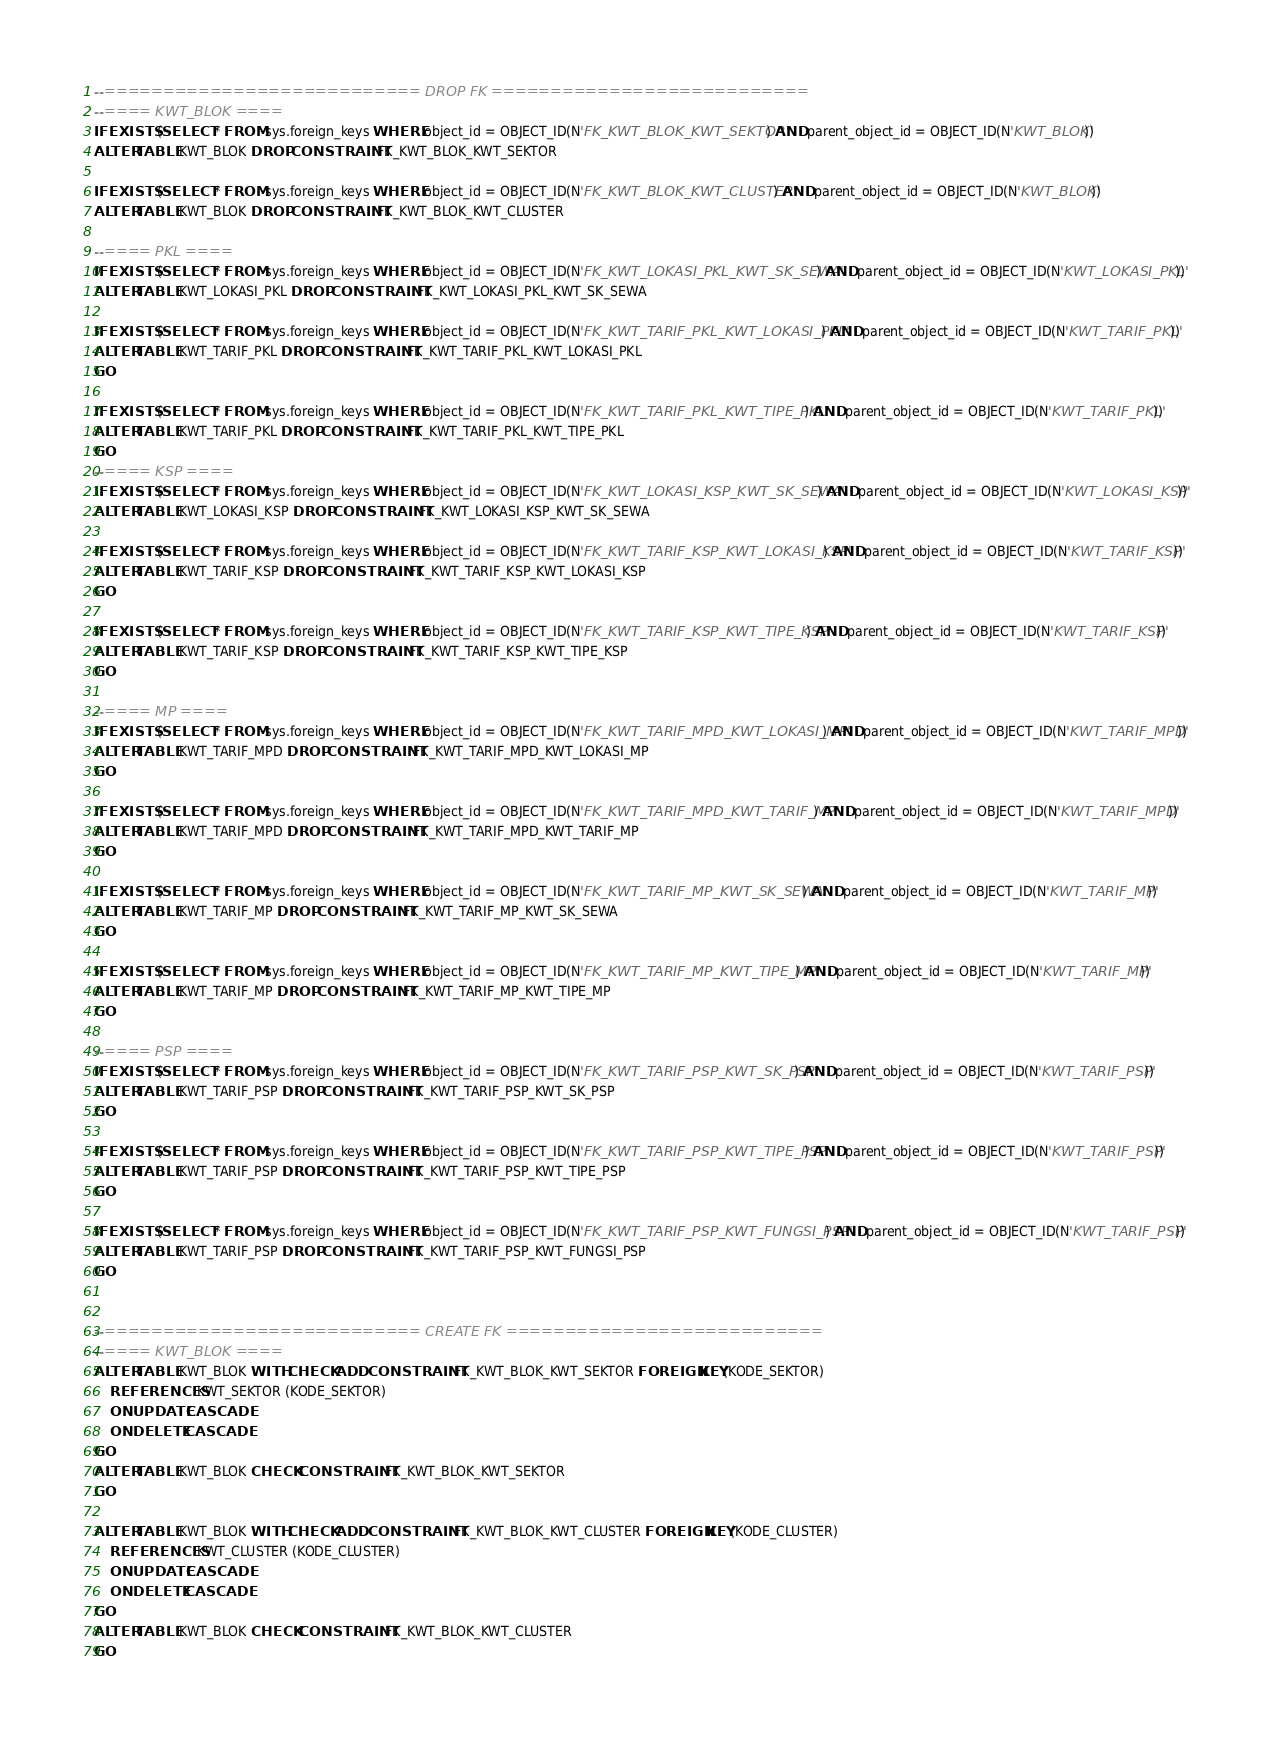Convert code to text. <code><loc_0><loc_0><loc_500><loc_500><_SQL_>--=========================== DROP FK ===========================
--==== KWT_BLOK ====
IF EXISTS (SELECT * FROM sys.foreign_keys WHERE object_id = OBJECT_ID(N'FK_KWT_BLOK_KWT_SEKTOR') AND parent_object_id = OBJECT_ID(N'KWT_BLOK'))
ALTER TABLE KWT_BLOK DROP CONSTRAINT FK_KWT_BLOK_KWT_SEKTOR

IF EXISTS (SELECT * FROM sys.foreign_keys WHERE object_id = OBJECT_ID(N'FK_KWT_BLOK_KWT_CLUSTER') AND parent_object_id = OBJECT_ID(N'KWT_BLOK'))
ALTER TABLE KWT_BLOK DROP CONSTRAINT FK_KWT_BLOK_KWT_CLUSTER

--==== PKL ====
IF EXISTS (SELECT * FROM sys.foreign_keys WHERE object_id = OBJECT_ID(N'FK_KWT_LOKASI_PKL_KWT_SK_SEWA') AND parent_object_id = OBJECT_ID(N'KWT_LOKASI_PKL'))
ALTER TABLE KWT_LOKASI_PKL DROP CONSTRAINT FK_KWT_LOKASI_PKL_KWT_SK_SEWA

IF EXISTS (SELECT * FROM sys.foreign_keys WHERE object_id = OBJECT_ID(N'FK_KWT_TARIF_PKL_KWT_LOKASI_PKL') AND parent_object_id = OBJECT_ID(N'KWT_TARIF_PKL'))
ALTER TABLE KWT_TARIF_PKL DROP CONSTRAINT FK_KWT_TARIF_PKL_KWT_LOKASI_PKL
GO

IF EXISTS (SELECT * FROM sys.foreign_keys WHERE object_id = OBJECT_ID(N'FK_KWT_TARIF_PKL_KWT_TIPE_PKL') AND parent_object_id = OBJECT_ID(N'KWT_TARIF_PKL'))
ALTER TABLE KWT_TARIF_PKL DROP CONSTRAINT FK_KWT_TARIF_PKL_KWT_TIPE_PKL
GO
--==== KSP ====
IF EXISTS (SELECT * FROM sys.foreign_keys WHERE object_id = OBJECT_ID(N'FK_KWT_LOKASI_KSP_KWT_SK_SEWA') AND parent_object_id = OBJECT_ID(N'KWT_LOKASI_KSP'))
ALTER TABLE KWT_LOKASI_KSP DROP CONSTRAINT FK_KWT_LOKASI_KSP_KWT_SK_SEWA

IF EXISTS (SELECT * FROM sys.foreign_keys WHERE object_id = OBJECT_ID(N'FK_KWT_TARIF_KSP_KWT_LOKASI_KSP') AND parent_object_id = OBJECT_ID(N'KWT_TARIF_KSP'))
ALTER TABLE KWT_TARIF_KSP DROP CONSTRAINT FK_KWT_TARIF_KSP_KWT_LOKASI_KSP
GO

IF EXISTS (SELECT * FROM sys.foreign_keys WHERE object_id = OBJECT_ID(N'FK_KWT_TARIF_KSP_KWT_TIPE_KSP') AND parent_object_id = OBJECT_ID(N'KWT_TARIF_KSP'))
ALTER TABLE KWT_TARIF_KSP DROP CONSTRAINT FK_KWT_TARIF_KSP_KWT_TIPE_KSP
GO

--==== MP ====
IF EXISTS (SELECT * FROM sys.foreign_keys WHERE object_id = OBJECT_ID(N'FK_KWT_TARIF_MPD_KWT_LOKASI_MP') AND parent_object_id = OBJECT_ID(N'KWT_TARIF_MPD'))
ALTER TABLE KWT_TARIF_MPD DROP CONSTRAINT FK_KWT_TARIF_MPD_KWT_LOKASI_MP
GO

IF EXISTS (SELECT * FROM sys.foreign_keys WHERE object_id = OBJECT_ID(N'FK_KWT_TARIF_MPD_KWT_TARIF_MP') AND parent_object_id = OBJECT_ID(N'KWT_TARIF_MPD'))
ALTER TABLE KWT_TARIF_MPD DROP CONSTRAINT FK_KWT_TARIF_MPD_KWT_TARIF_MP
GO

IF EXISTS (SELECT * FROM sys.foreign_keys WHERE object_id = OBJECT_ID(N'FK_KWT_TARIF_MP_KWT_SK_SEWA') AND parent_object_id = OBJECT_ID(N'KWT_TARIF_MP'))
ALTER TABLE KWT_TARIF_MP DROP CONSTRAINT FK_KWT_TARIF_MP_KWT_SK_SEWA
GO

IF EXISTS (SELECT * FROM sys.foreign_keys WHERE object_id = OBJECT_ID(N'FK_KWT_TARIF_MP_KWT_TIPE_MP') AND parent_object_id = OBJECT_ID(N'KWT_TARIF_MP'))
ALTER TABLE KWT_TARIF_MP DROP CONSTRAINT FK_KWT_TARIF_MP_KWT_TIPE_MP
GO

--==== PSP ====
IF EXISTS (SELECT * FROM sys.foreign_keys WHERE object_id = OBJECT_ID(N'FK_KWT_TARIF_PSP_KWT_SK_PSP') AND parent_object_id = OBJECT_ID(N'KWT_TARIF_PSP'))
ALTER TABLE KWT_TARIF_PSP DROP CONSTRAINT FK_KWT_TARIF_PSP_KWT_SK_PSP
GO

IF EXISTS (SELECT * FROM sys.foreign_keys WHERE object_id = OBJECT_ID(N'FK_KWT_TARIF_PSP_KWT_TIPE_PSP') AND parent_object_id = OBJECT_ID(N'KWT_TARIF_PSP'))
ALTER TABLE KWT_TARIF_PSP DROP CONSTRAINT FK_KWT_TARIF_PSP_KWT_TIPE_PSP
GO

IF EXISTS (SELECT * FROM sys.foreign_keys WHERE object_id = OBJECT_ID(N'FK_KWT_TARIF_PSP_KWT_FUNGSI_PSP') AND parent_object_id = OBJECT_ID(N'KWT_TARIF_PSP'))
ALTER TABLE KWT_TARIF_PSP DROP CONSTRAINT FK_KWT_TARIF_PSP_KWT_FUNGSI_PSP
GO


--=========================== CREATE FK ===========================
--==== KWT_BLOK ====
ALTER TABLE KWT_BLOK WITH CHECK ADD CONSTRAINT FK_KWT_BLOK_KWT_SEKTOR FOREIGN KEY(KODE_SEKTOR)
	REFERENCES KWT_SEKTOR (KODE_SEKTOR)
	ON UPDATE CASCADE
	ON DELETE CASCADE
GO
ALTER TABLE KWT_BLOK CHECK CONSTRAINT FK_KWT_BLOK_KWT_SEKTOR
GO

ALTER TABLE KWT_BLOK WITH CHECK ADD CONSTRAINT FK_KWT_BLOK_KWT_CLUSTER FOREIGN KEY(KODE_CLUSTER)
	REFERENCES KWT_CLUSTER (KODE_CLUSTER)
	ON UPDATE CASCADE
	ON DELETE CASCADE
GO
ALTER TABLE KWT_BLOK CHECK CONSTRAINT FK_KWT_BLOK_KWT_CLUSTER
GO

</code> 